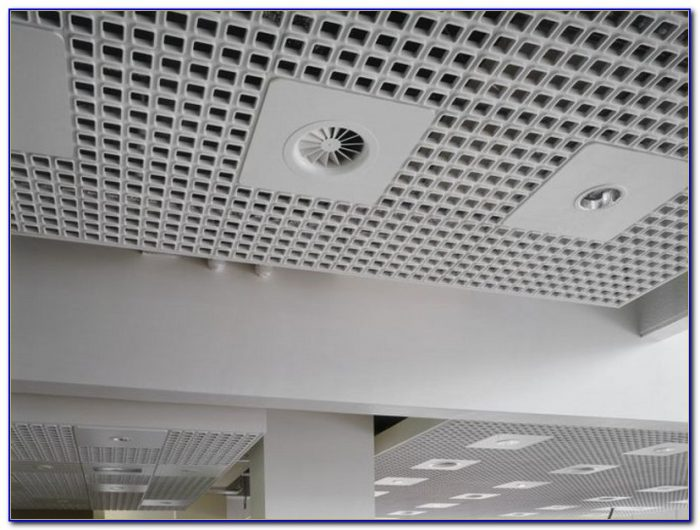How do the various fixtures integrated into the ceiling contribute to its overall functionality? The ceiling in the image features various fixtures, including air diffusers, lights, and possibly sensors, which are seamlessly integrated. These fixtures serve distinct but complementary functions. The air diffusers ensure comfortable air quality and circulation, crucial for maintaining a pleasant and healthful environment. The lighting fixtures are strategically placed to provide ample, even illumination, essential for productivity and comfort in any indoor space. Collectively, these elements contribute not only to the functional utility of the ceiling but also to its aesthetic appeal, creating a cohesive and modern design. 